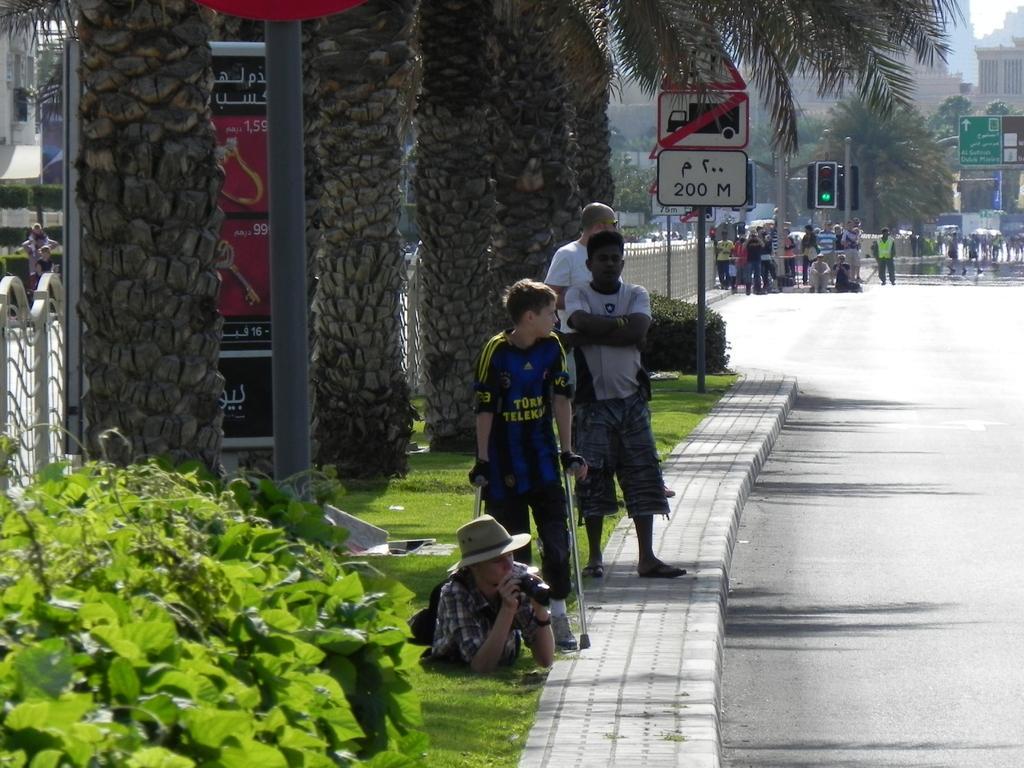Could you give a brief overview of what you see in this image? In this image, we can see people and vehicles on the road. In the background, there are buildings, trees, boards, poles and we can see a railing, some plants and there are some people on the sidewalk and one of them is wearing a hat and holding an object and a boy is holding sticks. 